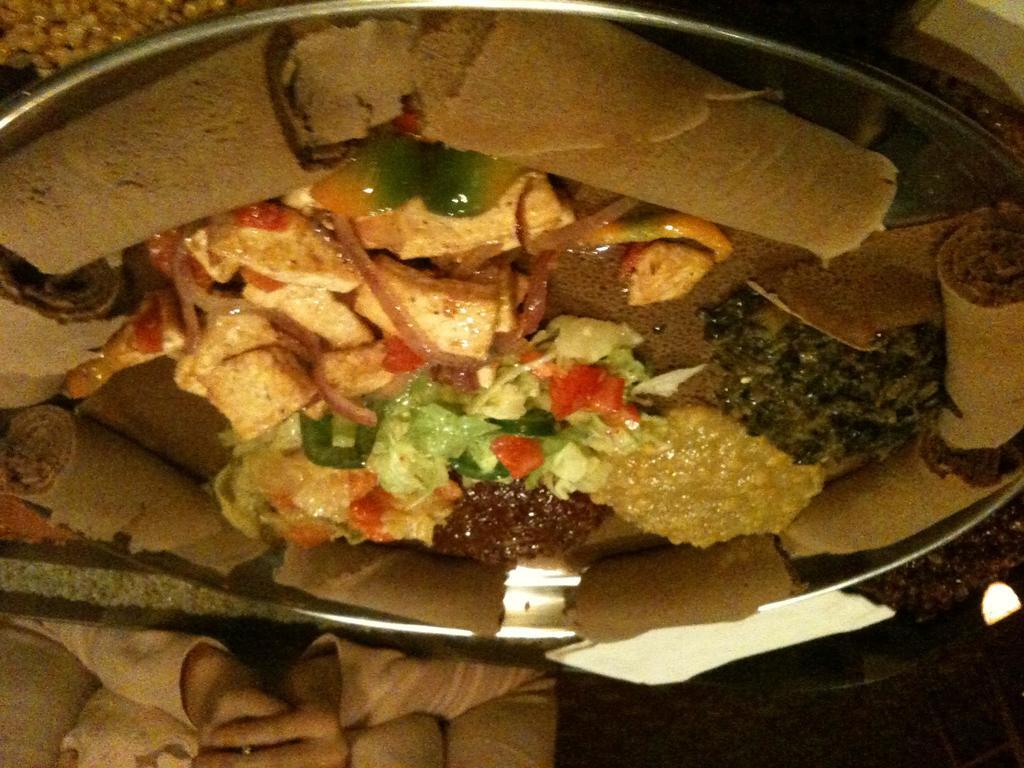In one or two sentences, can you explain what this image depicts? In this image we can see some food items in the plate, also we can see the hands of a person. 